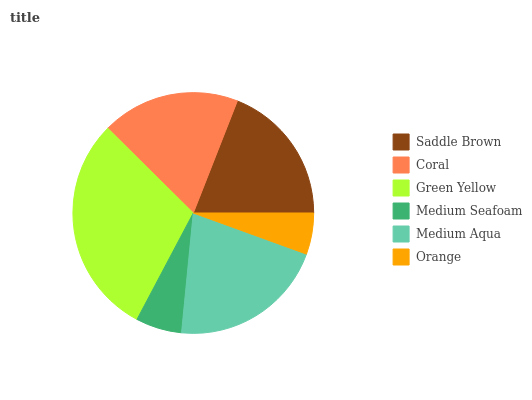Is Orange the minimum?
Answer yes or no. Yes. Is Green Yellow the maximum?
Answer yes or no. Yes. Is Coral the minimum?
Answer yes or no. No. Is Coral the maximum?
Answer yes or no. No. Is Saddle Brown greater than Coral?
Answer yes or no. Yes. Is Coral less than Saddle Brown?
Answer yes or no. Yes. Is Coral greater than Saddle Brown?
Answer yes or no. No. Is Saddle Brown less than Coral?
Answer yes or no. No. Is Saddle Brown the high median?
Answer yes or no. Yes. Is Coral the low median?
Answer yes or no. Yes. Is Medium Seafoam the high median?
Answer yes or no. No. Is Medium Seafoam the low median?
Answer yes or no. No. 